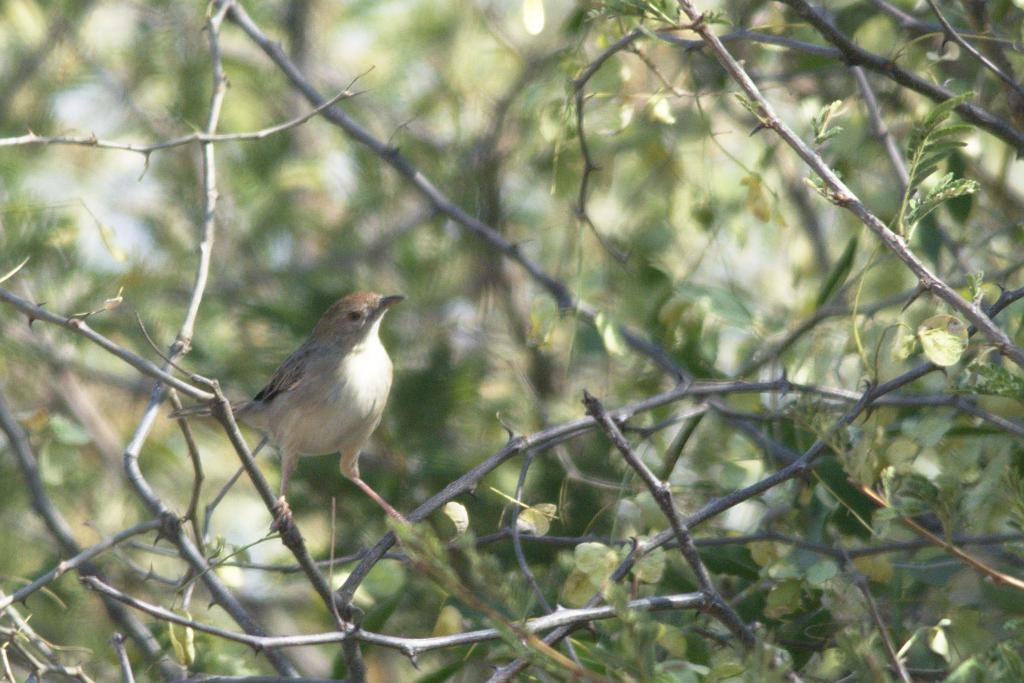What is the main subject of the image? There is a bird in the center of the image. Can you describe the background of the image? The background of the image is blurred. What type of stamp can be seen on the bird's wing in the image? There is no stamp present on the bird's wing in the image. How does the fog affect the visibility of the bird in the image? There is no fog present in the image; the bird is clearly visible. 